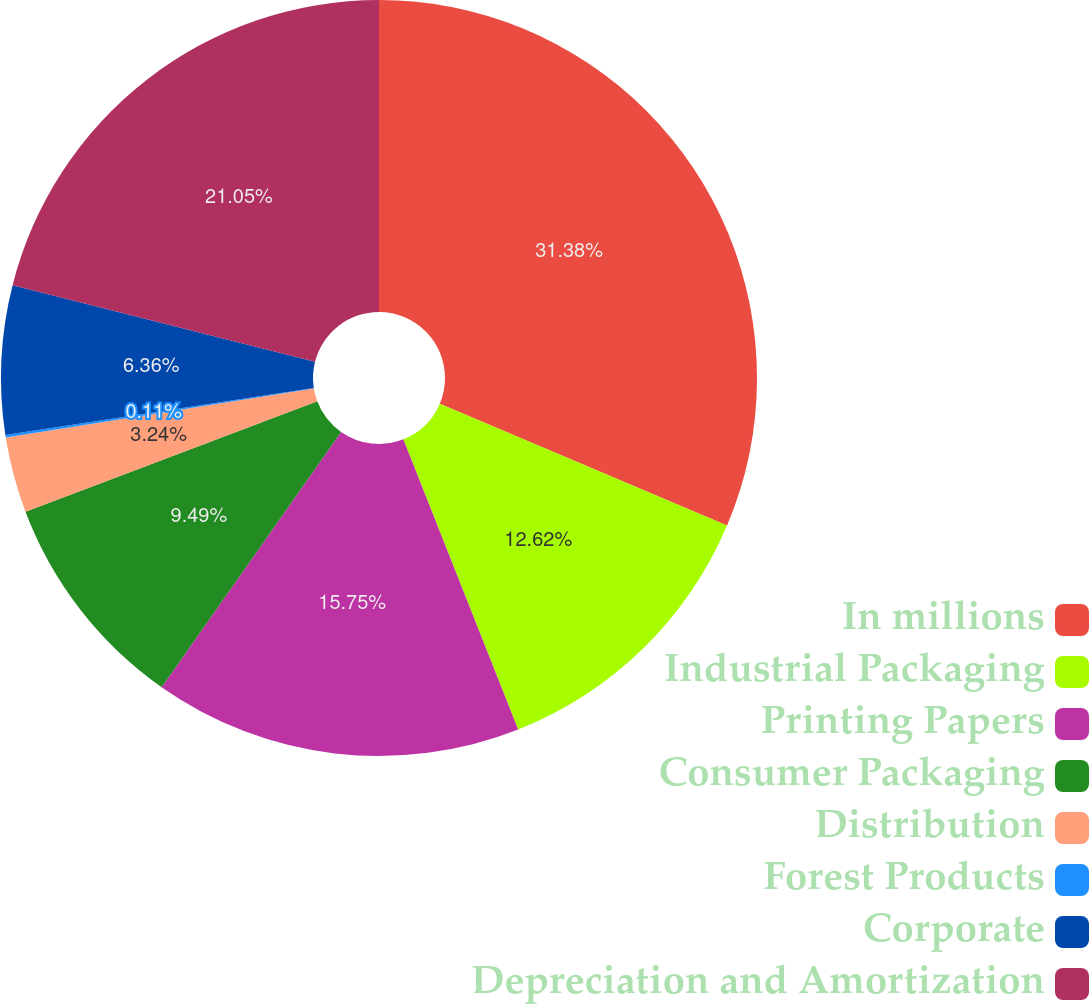<chart> <loc_0><loc_0><loc_500><loc_500><pie_chart><fcel>In millions<fcel>Industrial Packaging<fcel>Printing Papers<fcel>Consumer Packaging<fcel>Distribution<fcel>Forest Products<fcel>Corporate<fcel>Depreciation and Amortization<nl><fcel>31.38%<fcel>12.62%<fcel>15.75%<fcel>9.49%<fcel>3.24%<fcel>0.11%<fcel>6.36%<fcel>21.05%<nl></chart> 